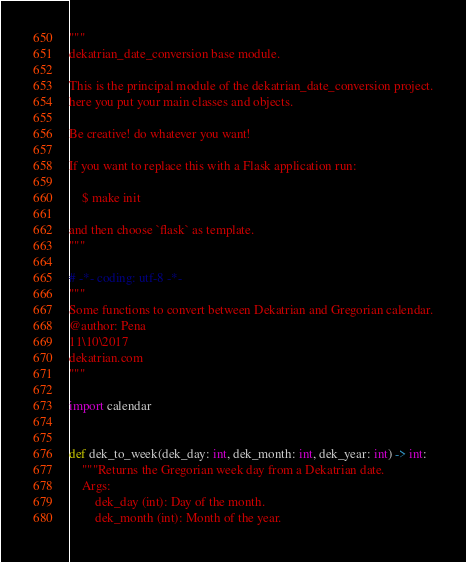<code> <loc_0><loc_0><loc_500><loc_500><_Python_>"""
dekatrian_date_conversion base module.

This is the principal module of the dekatrian_date_conversion project.
here you put your main classes and objects.

Be creative! do whatever you want!

If you want to replace this with a Flask application run:

    $ make init

and then choose `flask` as template.
"""

# -*- coding: utf-8 -*-
"""
Some functions to convert between Dekatrian and Gregorian calendar.
@author: Pena
11\10\2017
dekatrian.com
"""

import calendar


def dek_to_week(dek_day: int, dek_month: int, dek_year: int) -> int:
    """Returns the Gregorian week day from a Dekatrian date.
    Args:
        dek_day (int): Day of the month.
        dek_month (int): Month of the year.</code> 